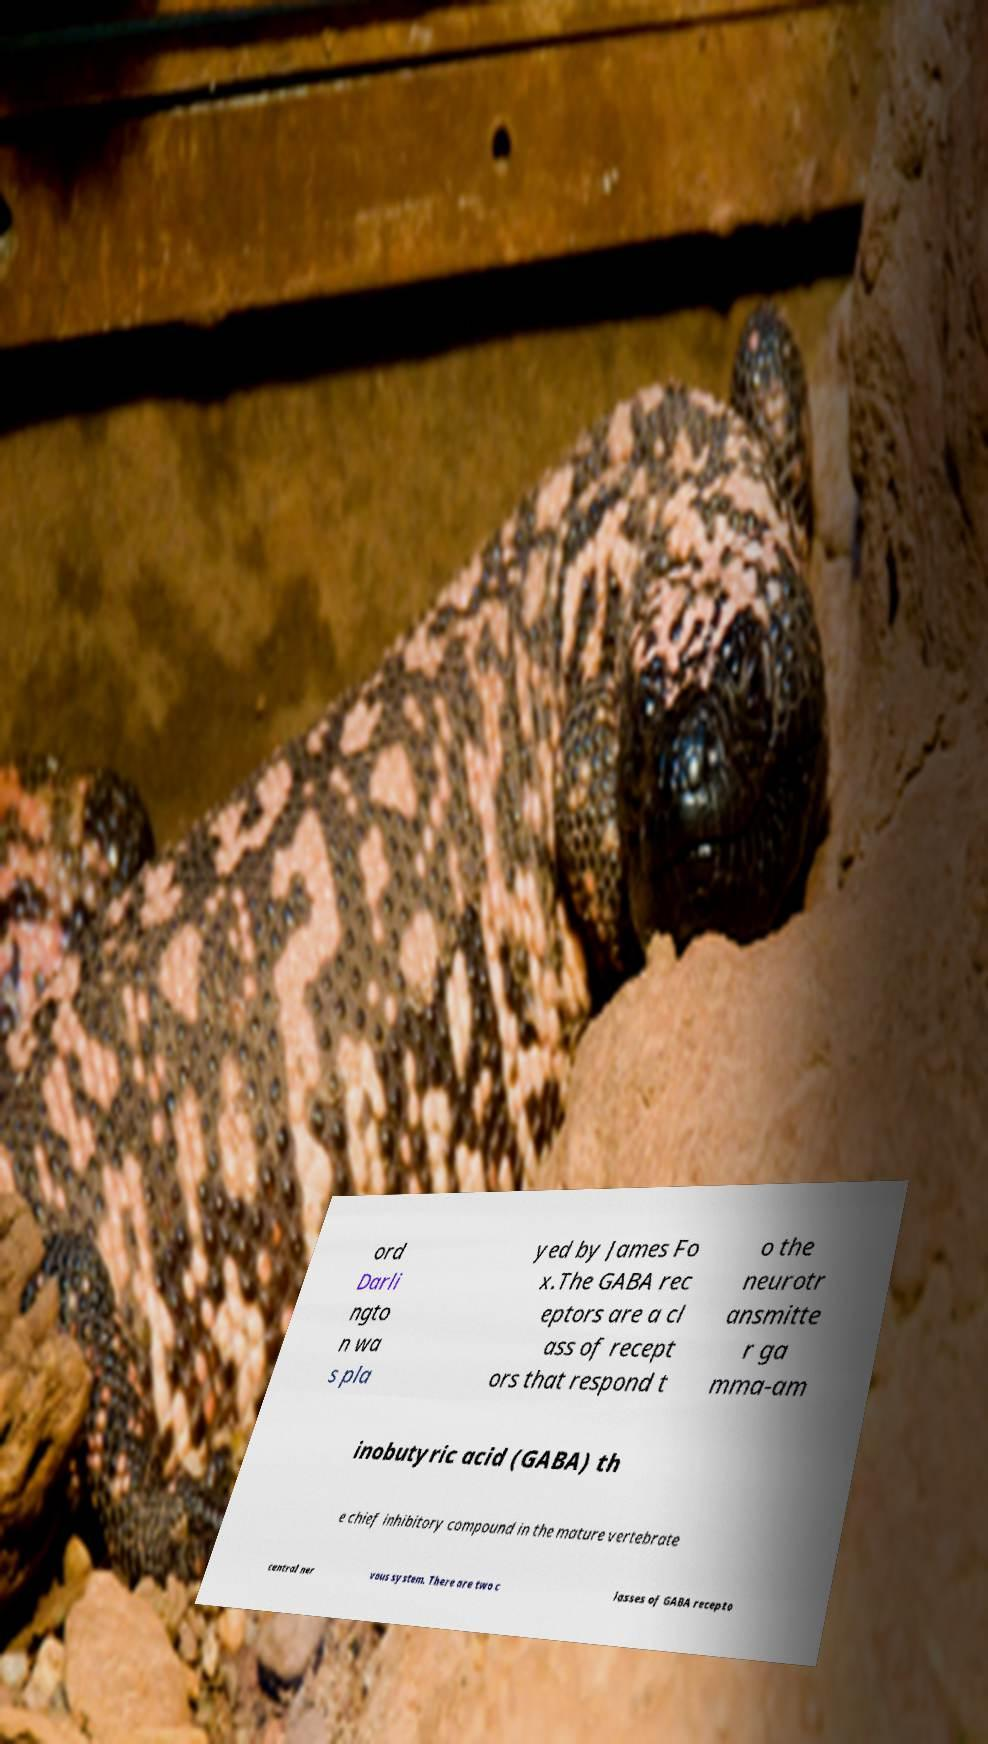Can you accurately transcribe the text from the provided image for me? ord Darli ngto n wa s pla yed by James Fo x.The GABA rec eptors are a cl ass of recept ors that respond t o the neurotr ansmitte r ga mma-am inobutyric acid (GABA) th e chief inhibitory compound in the mature vertebrate central ner vous system. There are two c lasses of GABA recepto 